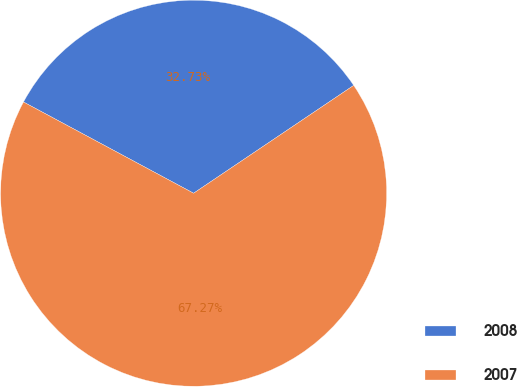<chart> <loc_0><loc_0><loc_500><loc_500><pie_chart><fcel>2008<fcel>2007<nl><fcel>32.73%<fcel>67.27%<nl></chart> 